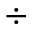<formula> <loc_0><loc_0><loc_500><loc_500>\div</formula> 